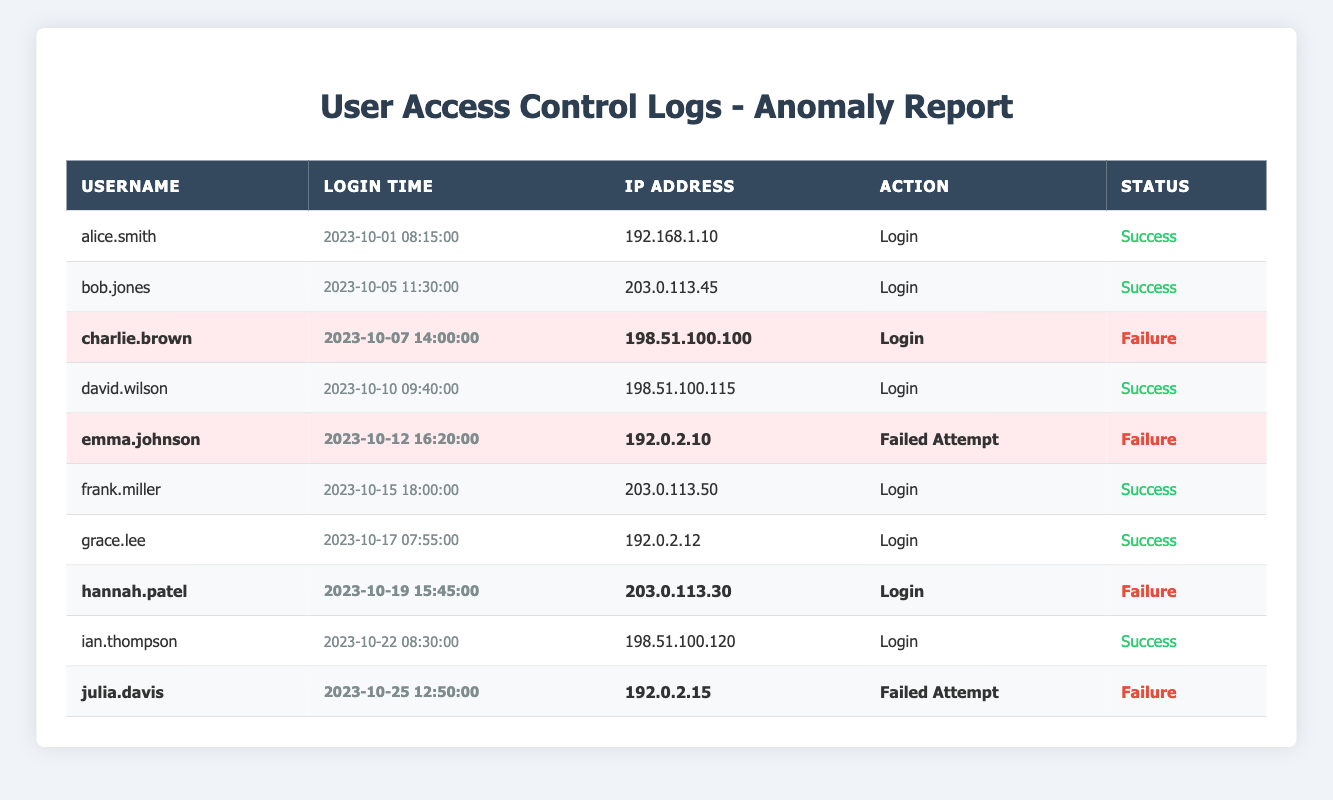What is the username associated with the first successful login? The first entry in the table with a status of "Success" is for the user "alice.smith" on 2023-10-01.
Answer: alice.smith How many total login attempts were recorded in the logs? There are 10 entries in the table, each representing a login attempt, either successful or failed.
Answer: 10 What percentage of the login attempts resulted in failure? There are 4 failed attempts out of 10 total attempts, so (4/10) * 100 = 40%.
Answer: 40% Which user experienced a login failure on October 7th? The entry for 2023-10-07 shows that "charlie.brown" had a failed login attempt.
Answer: charlie.brown Is there a pattern of successful logins after failed login attempts? Users such as "david.wilson" logged in successfully following "charlie.brown" and "emma.johnson", whose attempts failed on earlier dates.
Answer: Yes How many unique users are recorded in the table? There are 8 unique usernames in the logs: alice.smith, bob.jones, charlie.brown, david.wilson, emma.johnson, frank.miller, grace.lee, hannah.patel, ian.thompson, and julia.davis.
Answer: 10 What is the most recent failed login attempt? The most recent entry with a failure status is attributed to "julia.davis" on 2023-10-25.
Answer: julia.davis How many anomalies were detected in the user access logs? There are 4 entries marked as anomalies in the logs for users charlie.brown, emma.johnson, hannah.patel, and julia.davis.
Answer: 4 What time did the first login failure occur? The first login failure was recorded on 2023-10-07 at 14:00:00 for the user "charlie.brown".
Answer: 14:00:00 Which IP address was used for the successful login by "ian.thompson"? The IP address "198.51.100.120" was used when "ian.thompson" successfully logged in.
Answer: 198.51.100.120 